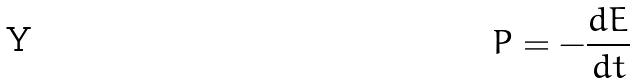<formula> <loc_0><loc_0><loc_500><loc_500>P = - \frac { d E } { d t }</formula> 